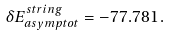Convert formula to latex. <formula><loc_0><loc_0><loc_500><loc_500>\delta E ^ { s t r i n g } _ { a s y m p t o t } = - 7 7 . 7 8 1 \, .</formula> 